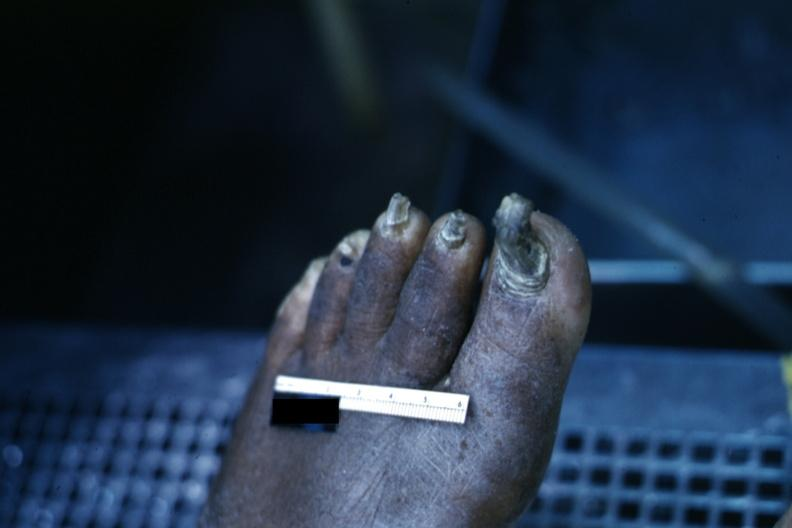re extremities present?
Answer the question using a single word or phrase. Yes 